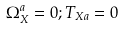<formula> <loc_0><loc_0><loc_500><loc_500>\Omega _ { X } ^ { a } = 0 ; T _ { X a } = 0</formula> 